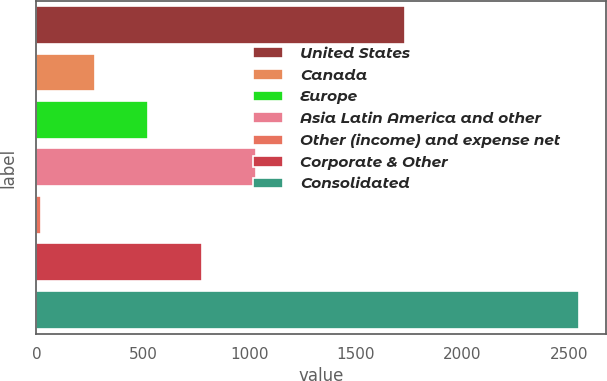Convert chart to OTSL. <chart><loc_0><loc_0><loc_500><loc_500><bar_chart><fcel>United States<fcel>Canada<fcel>Europe<fcel>Asia Latin America and other<fcel>Other (income) and expense net<fcel>Corporate & Other<fcel>Consolidated<nl><fcel>1730<fcel>272.7<fcel>525.4<fcel>1030.8<fcel>20<fcel>778.1<fcel>2547<nl></chart> 